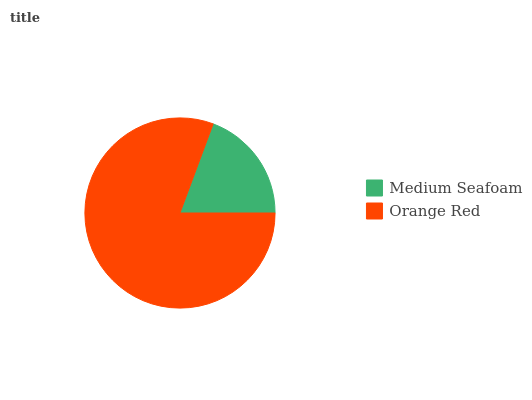Is Medium Seafoam the minimum?
Answer yes or no. Yes. Is Orange Red the maximum?
Answer yes or no. Yes. Is Orange Red the minimum?
Answer yes or no. No. Is Orange Red greater than Medium Seafoam?
Answer yes or no. Yes. Is Medium Seafoam less than Orange Red?
Answer yes or no. Yes. Is Medium Seafoam greater than Orange Red?
Answer yes or no. No. Is Orange Red less than Medium Seafoam?
Answer yes or no. No. Is Orange Red the high median?
Answer yes or no. Yes. Is Medium Seafoam the low median?
Answer yes or no. Yes. Is Medium Seafoam the high median?
Answer yes or no. No. Is Orange Red the low median?
Answer yes or no. No. 